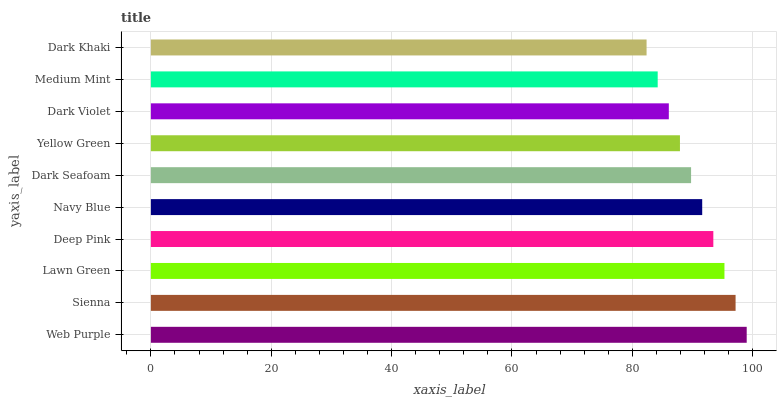Is Dark Khaki the minimum?
Answer yes or no. Yes. Is Web Purple the maximum?
Answer yes or no. Yes. Is Sienna the minimum?
Answer yes or no. No. Is Sienna the maximum?
Answer yes or no. No. Is Web Purple greater than Sienna?
Answer yes or no. Yes. Is Sienna less than Web Purple?
Answer yes or no. Yes. Is Sienna greater than Web Purple?
Answer yes or no. No. Is Web Purple less than Sienna?
Answer yes or no. No. Is Navy Blue the high median?
Answer yes or no. Yes. Is Dark Seafoam the low median?
Answer yes or no. Yes. Is Dark Seafoam the high median?
Answer yes or no. No. Is Medium Mint the low median?
Answer yes or no. No. 